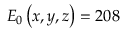Convert formula to latex. <formula><loc_0><loc_0><loc_500><loc_500>E _ { 0 } \left ( x , y , z \right ) = 2 0 8</formula> 